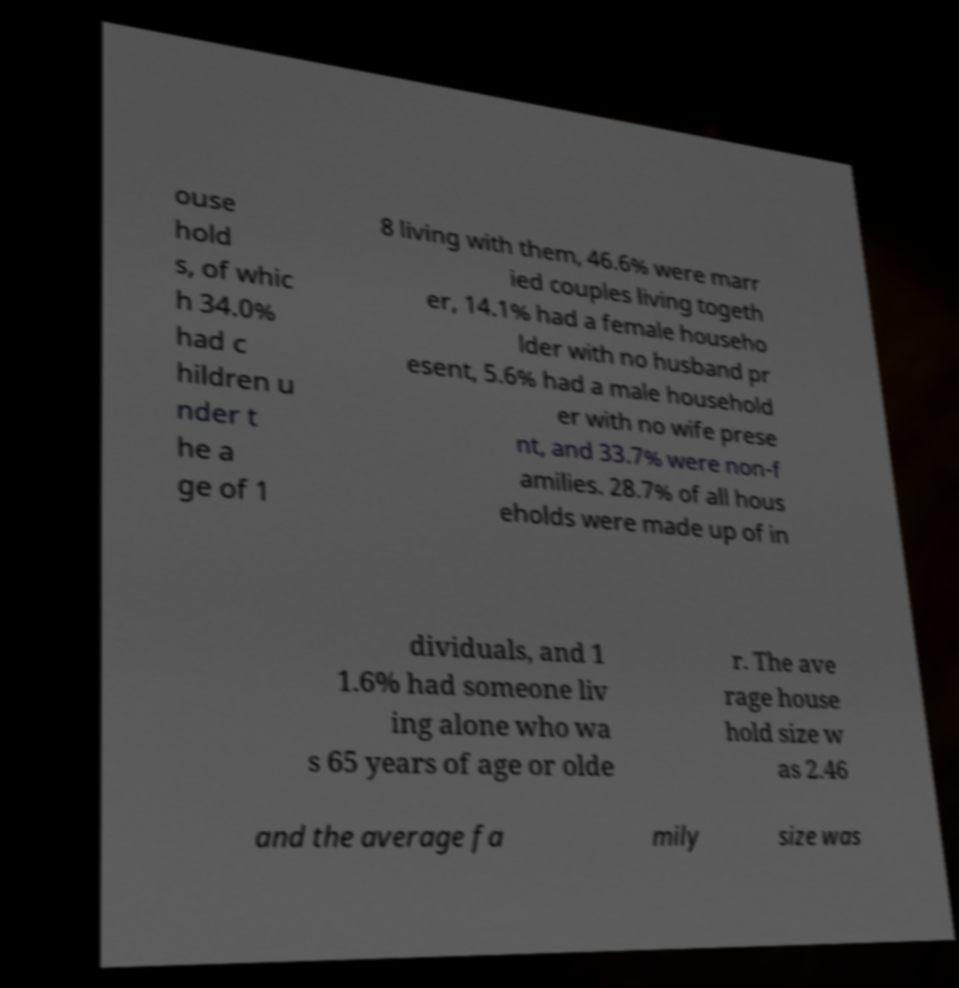Can you read and provide the text displayed in the image?This photo seems to have some interesting text. Can you extract and type it out for me? ouse hold s, of whic h 34.0% had c hildren u nder t he a ge of 1 8 living with them, 46.6% were marr ied couples living togeth er, 14.1% had a female househo lder with no husband pr esent, 5.6% had a male household er with no wife prese nt, and 33.7% were non-f amilies. 28.7% of all hous eholds were made up of in dividuals, and 1 1.6% had someone liv ing alone who wa s 65 years of age or olde r. The ave rage house hold size w as 2.46 and the average fa mily size was 